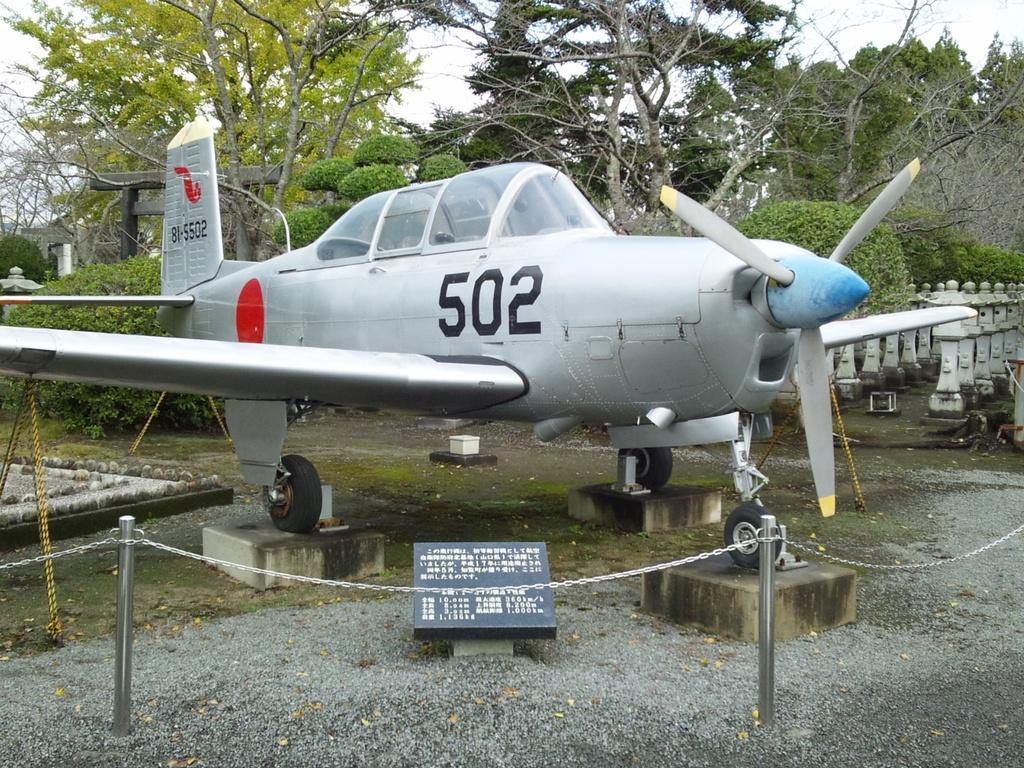In one or two sentences, can you explain what this image depicts? In this there is a helicopter which is in grey in color. Around it there are poles with chains. In the background, there are trees and sky. 